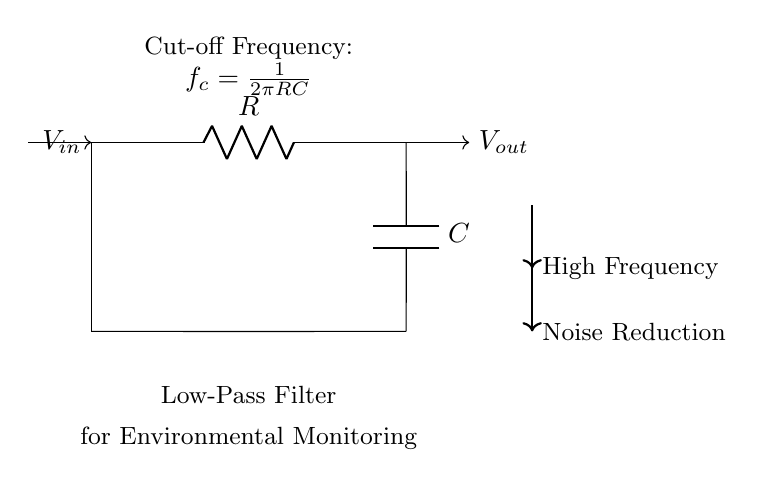What type of filter is this circuit? The circuit is specifically identified as a low-pass filter, indicated by the configuration of the resistor and capacitor and the labeling in the diagram.
Answer: Low-pass filter What is the function of the capacitor in this circuit? The capacitor provides the essential filtering function by allowing low-frequency signals to pass while impeding high-frequency noise. This feature defines its role in noise reduction.
Answer: Noise reduction What is represented by the variable 'R' in the circuit? The variable 'R' stands for the resistor in this low-pass filter circuit, which, along with the capacitor, determines the filter's performance characteristics like cut-off frequency.
Answer: Resistor How is the cut-off frequency calculated? The cut-off frequency is calculated using the formula provided, which involves both R and C values. The equation shows that both components directly influence the cut-off frequency, thus highlighting their significance.
Answer: 1 over 2 pi RC What happens to high-frequency signals in this circuit? High-frequency signals are attenuated or blocked by the low-pass filter, which is designed to suppress noise and only allow lower frequencies to pass through, thereby improving signal quality for measurements.
Answer: Attenuated Which component dictates the cut-off frequency? Both the resistor and capacitor together determine the cut-off frequency, as shown by the formula where 'f_c' depends on the product of these two components.
Answer: Resistor and capacitor What are the input and output voltages labeled as? The input voltage is labeled as V_in, and the output voltage is labeled as V_out in the circuit diagram, clearly indicating the points of measurement for signals before and after the filtering effect.
Answer: V_in and V_out 